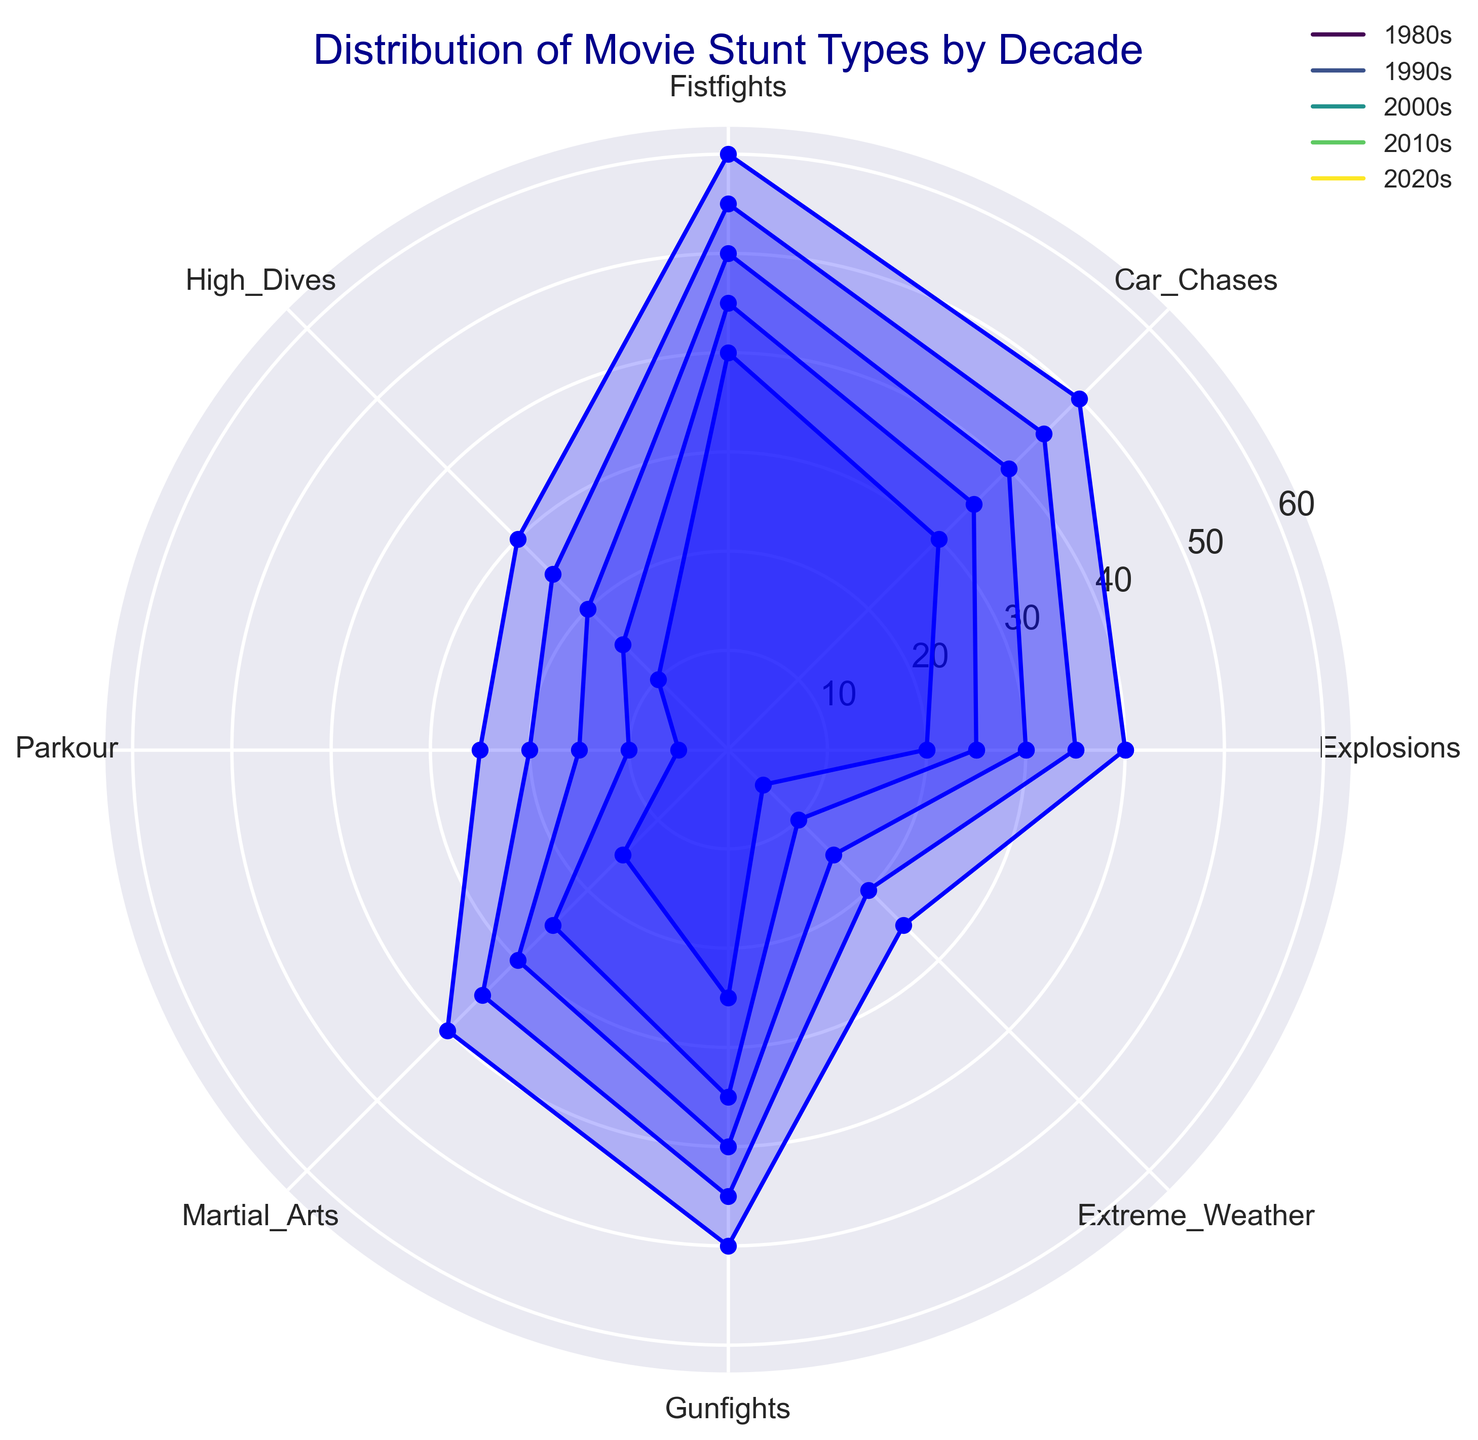Which decade has the highest number of fistfights? Review the radar chart's Fistfights section across all decades and identify the one with the largest value. The largest value observed for Fistfights is 60 in the 2020s.
Answer: 2020s What is the average number of parkour stunts from the 1980s to the 2020s? Extract the Parkour values for each decade (5, 10, 15, 20, 25), sum them up (75), and then divide by the number of decades (5). Calculate 75/5 = 15.
Answer: 15 How does the occurrence of explosions in the 1980s compare to the 2020s? Look at the values for Explosions in the 1980s (20) and the 2020s (40). The number in the 2020s is double that in the 1980s.
Answer: The 2020s have twice the explosions of the 1980s Which decade witnessed the least number of high dives? Identify the smallest value for High Dives across all decades. The smallest value is 10 in the 1980s.
Answer: 1980s What is the total number of gunfights in the 1990s and 2010s? Sum the values of Gunfights in the 1990s (35) and 2010s (45). Perform the calculation 35 + 45 = 80.
Answer: 80 Are car chases more common in the 2000s or 2010s? Check the Car Chases values for the 2000s (40) and 2010s (45). Notice that the value in the 2010s is higher.
Answer: More common in the 2010s What is the range of martial arts stunts across all decades? Identify the maximum (40 in the 2020s) and minimum (15 in the 1980s) values for Martial Arts, and calculate the range as 40 - 15 = 25.
Answer: 25 Which stunt type grew the most from the 1980s to the 2020s? For each stunt type, find the difference between 2020s and 1980s. Highest increase is for Fistfights (60 - 40 = 20).
Answer: Fistfights What’s the average number of stunts per category in the 2010s? Sum the stunt values of the 2010s (35+45+55+25+20+35+45+20 = 280) and divide by the number of categories (8). Calculate 280/8 = 35.
Answer: 35 In which decades are extreme weather stunts most and least common? Compare Extreme Weather values across all decades and identify the highest (25 in the 2020s) and lowest (5 in the 1980s).
Answer: Most in the 2020s, least in the 1980s 